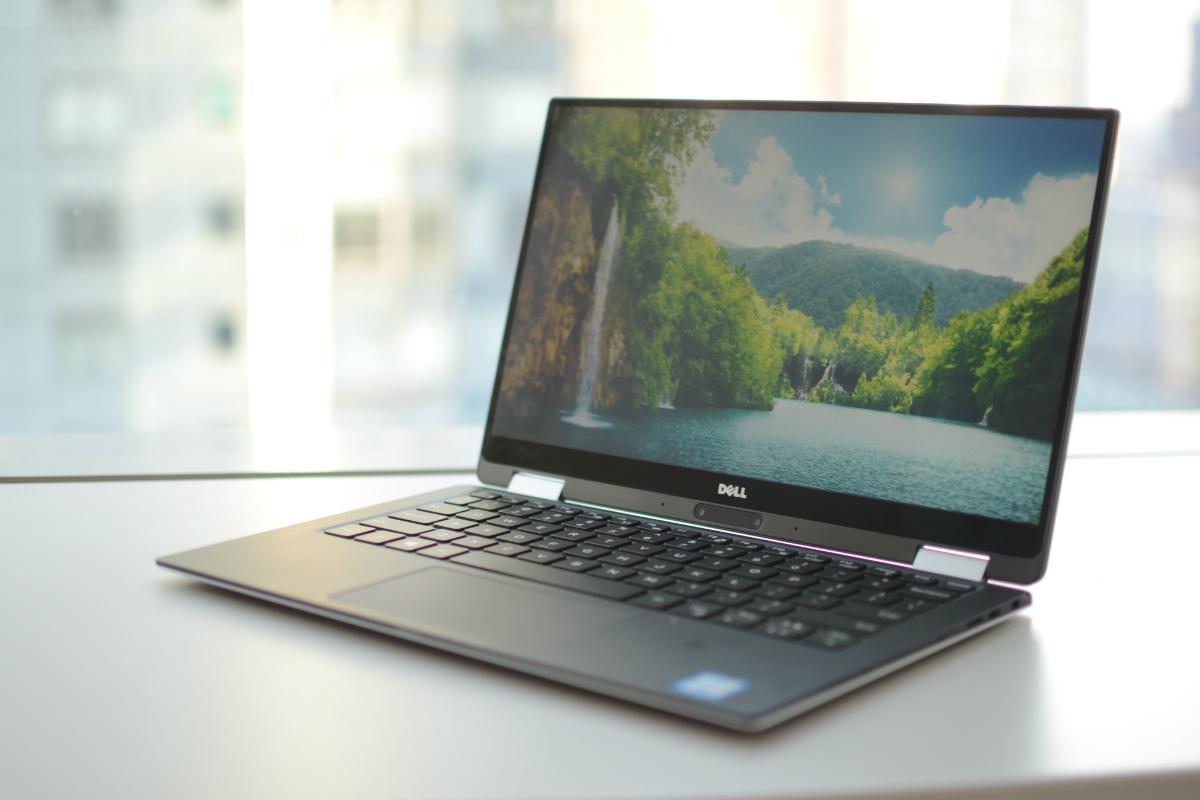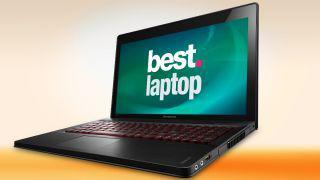The first image is the image on the left, the second image is the image on the right. For the images displayed, is the sentence "Both images show an open laptop tilted so the screen aims leftward." factually correct? Answer yes or no. Yes. The first image is the image on the left, the second image is the image on the right. Assess this claim about the two images: "Both computers are facing the left.". Correct or not? Answer yes or no. Yes. 